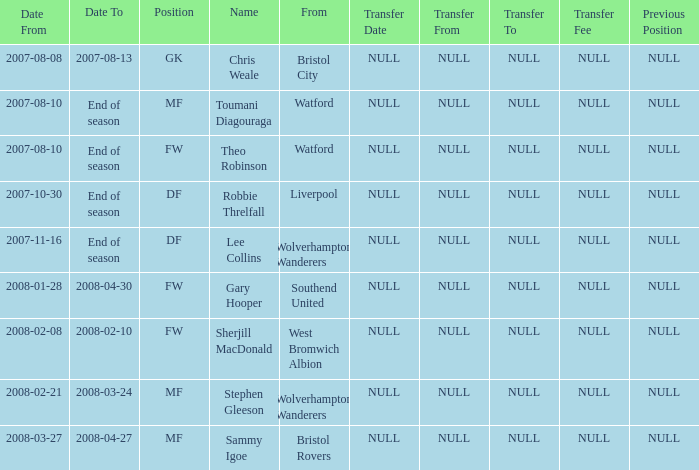What was the label for the row with date from of 2008-02-21? Stephen Gleeson. 